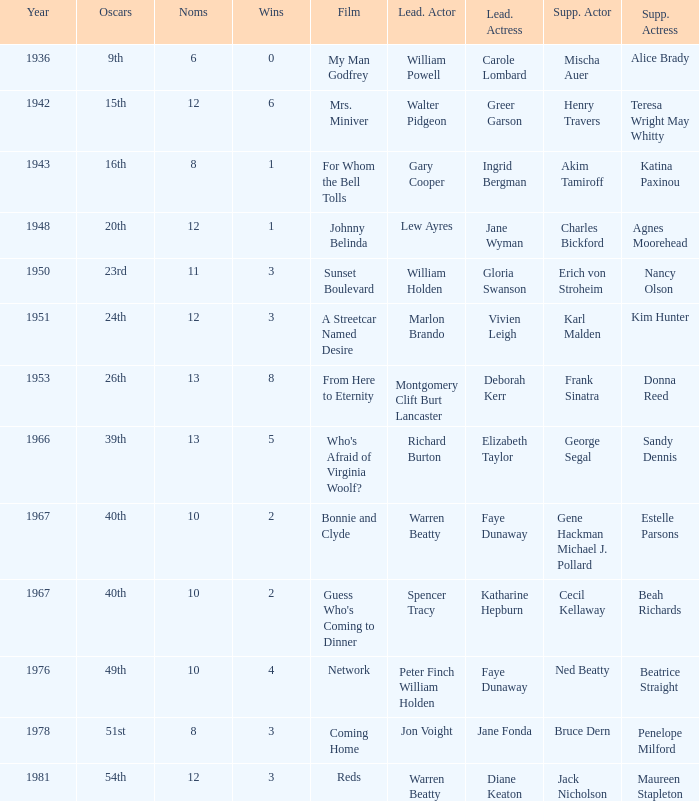Which film had Charles Bickford as supporting actor? Johnny Belinda. Could you parse the entire table as a dict? {'header': ['Year', 'Oscars', 'Noms', 'Wins', 'Film', 'Lead. Actor', 'Lead. Actress', 'Supp. Actor', 'Supp. Actress'], 'rows': [['1936', '9th', '6', '0', 'My Man Godfrey', 'William Powell', 'Carole Lombard', 'Mischa Auer', 'Alice Brady'], ['1942', '15th', '12', '6', 'Mrs. Miniver', 'Walter Pidgeon', 'Greer Garson', 'Henry Travers', 'Teresa Wright May Whitty'], ['1943', '16th', '8', '1', 'For Whom the Bell Tolls', 'Gary Cooper', 'Ingrid Bergman', 'Akim Tamiroff', 'Katina Paxinou'], ['1948', '20th', '12', '1', 'Johnny Belinda', 'Lew Ayres', 'Jane Wyman', 'Charles Bickford', 'Agnes Moorehead'], ['1950', '23rd', '11', '3', 'Sunset Boulevard', 'William Holden', 'Gloria Swanson', 'Erich von Stroheim', 'Nancy Olson'], ['1951', '24th', '12', '3', 'A Streetcar Named Desire', 'Marlon Brando', 'Vivien Leigh', 'Karl Malden', 'Kim Hunter'], ['1953', '26th', '13', '8', 'From Here to Eternity', 'Montgomery Clift Burt Lancaster', 'Deborah Kerr', 'Frank Sinatra', 'Donna Reed'], ['1966', '39th', '13', '5', "Who's Afraid of Virginia Woolf?", 'Richard Burton', 'Elizabeth Taylor', 'George Segal', 'Sandy Dennis'], ['1967', '40th', '10', '2', 'Bonnie and Clyde', 'Warren Beatty', 'Faye Dunaway', 'Gene Hackman Michael J. Pollard', 'Estelle Parsons'], ['1967', '40th', '10', '2', "Guess Who's Coming to Dinner", 'Spencer Tracy', 'Katharine Hepburn', 'Cecil Kellaway', 'Beah Richards'], ['1976', '49th', '10', '4', 'Network', 'Peter Finch William Holden', 'Faye Dunaway', 'Ned Beatty', 'Beatrice Straight'], ['1978', '51st', '8', '3', 'Coming Home', 'Jon Voight', 'Jane Fonda', 'Bruce Dern', 'Penelope Milford'], ['1981', '54th', '12', '3', 'Reds', 'Warren Beatty', 'Diane Keaton', 'Jack Nicholson', 'Maureen Stapleton']]} 